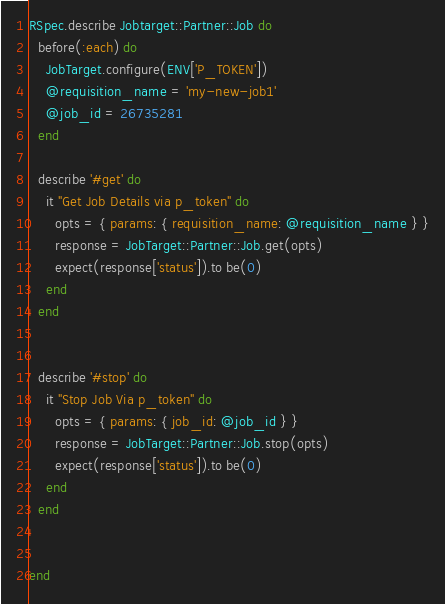<code> <loc_0><loc_0><loc_500><loc_500><_Ruby_>RSpec.describe Jobtarget::Partner::Job do
  before(:each) do
    JobTarget.configure(ENV['P_TOKEN'])
    @requisition_name = 'my-new-job1'
    @job_id = 26735281
  end

  describe '#get' do
    it "Get Job Details via p_token" do
      opts = { params: { requisition_name: @requisition_name } }
      response = JobTarget::Partner::Job.get(opts)
      expect(response['status']).to be(0)
    end
  end


  describe '#stop' do
    it "Stop Job Via p_token" do
      opts = { params: { job_id: @job_id } }
      response = JobTarget::Partner::Job.stop(opts)
      expect(response['status']).to be(0)
    end
  end


end</code> 